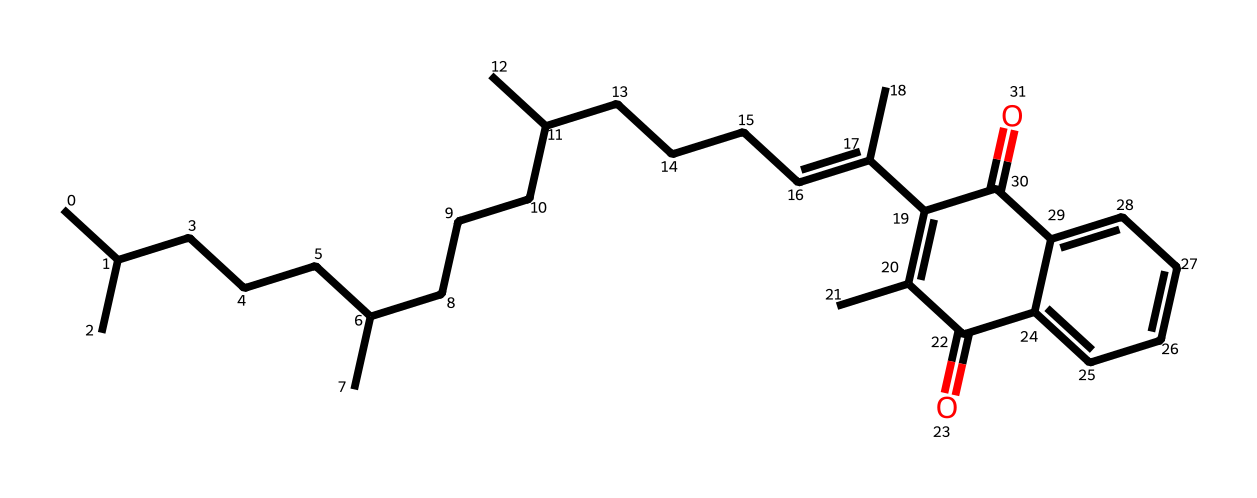how many rings are present in this molecule? The provided SMILES indicates that there is one cyclic structure denoted by "C1" which signifies the start and end of a ring. By counting the atoms connected in a circular fashion, we identify this as having one ring.
Answer: one what types of functional groups are present in vitamin K? Analyzing the SMILES, there are two carbonyl groups (C=O), which are indicative of ketone functional groups, as seen in the simplified sections of the structure. Hence, it has ketone groups.
Answer: ketone what is the primary role of vitamin K in the body? Vitamin K is known primarily for its crucial involvement in blood coagulation. This role is well-established in the literature and clinical research on vitamin K functions.
Answer: blood coagulation how many double bonds are present in the structure? The SMILES representation contains a "=C" notation, indicating one double bond between carbon atoms. Upon careful inspection, we don’t find additional double bonds elsewhere in the structure. Thus, there is one double bond.
Answer: one what is the main use of vitamin K in medicine? Vitamin K is widely utilized in clinical settings to reverse anticoagulant effects, particularly in patients requiring vitamin K for proper clotting factor synthesis after anticoagulation therapy.
Answer: anticoagulant reversal how does vitamin K affect bone metabolism? Vitamin K plays a role in the synthesis of osteocalcin, a protein involved in bone mineralization, which is essential for maintaining bone health and density. This also links vitamin K's role to calcium regulation.
Answer: osteocalcin synthesis what is the relationship between vitamin K and clotting factors? Vitamin K is essential for the post-translational modifications of specific clotting factors, including factors II, VII, IX, and X, which are necessary for their function in the coagulation cascade.
Answer: factor modification 